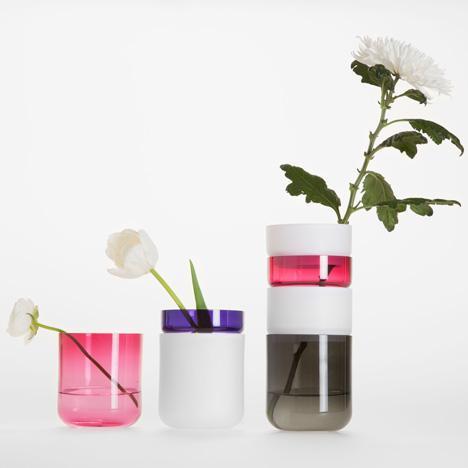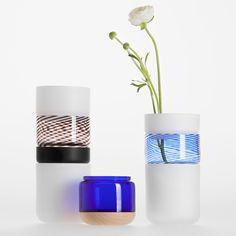The first image is the image on the left, the second image is the image on the right. Analyze the images presented: Is the assertion "All photos have exactly three vases or jars positioned in close proximity to each other." valid? Answer yes or no. Yes. The first image is the image on the left, the second image is the image on the right. Evaluate the accuracy of this statement regarding the images: "all vases have muted colors and some with flowers". Is it true? Answer yes or no. Yes. 